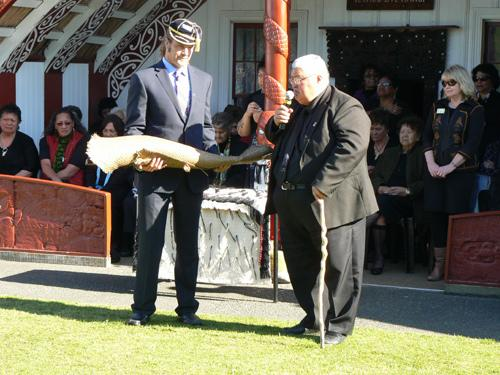What is the thin object the man holding the microphone is using to prop up called? Please explain your reasoning. cane. The object is the length of the height of the man's waist to the ground.   it is about the width of five fingers.  it is sturdy and can hold a lot of weight without breaking. 